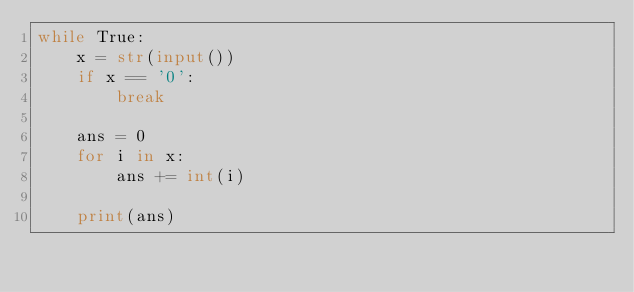Convert code to text. <code><loc_0><loc_0><loc_500><loc_500><_Python_>while True:
    x = str(input())
    if x == '0':
        break
    
    ans = 0
    for i in x:
        ans += int(i)
    
    print(ans)
</code> 